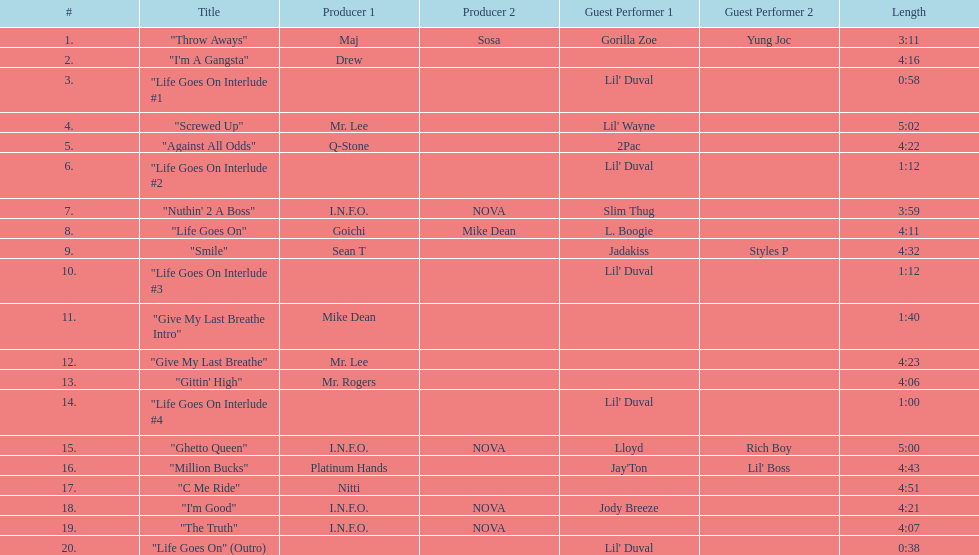What is the total number of tracks on the album? 20. Could you parse the entire table as a dict? {'header': ['#', 'Title', 'Producer 1', 'Producer 2', 'Guest Performer 1', 'Guest Performer 2', 'Length'], 'rows': [['1.', '"Throw Aways"', 'Maj', 'Sosa', 'Gorilla Zoe', 'Yung Joc', '3:11'], ['2.', '"I\'m A Gangsta"', 'Drew', '', '', '', '4:16'], ['3.', '"Life Goes On Interlude #1', '', '', "Lil' Duval", '', '0:58'], ['4.', '"Screwed Up"', 'Mr. Lee', '', "Lil' Wayne", '', '5:02'], ['5.', '"Against All Odds"', 'Q-Stone', '', '2Pac', '', '4:22'], ['6.', '"Life Goes On Interlude #2', '', '', "Lil' Duval", '', '1:12'], ['7.', '"Nuthin\' 2 A Boss"', 'I.N.F.O.', 'NOVA', 'Slim Thug', '', '3:59'], ['8.', '"Life Goes On"', 'Goichi', 'Mike Dean', 'L. Boogie', '', '4:11'], ['9.', '"Smile"', 'Sean T', '', 'Jadakiss', 'Styles P', '4:32'], ['10.', '"Life Goes On Interlude #3', '', '', "Lil' Duval", '', '1:12'], ['11.', '"Give My Last Breathe Intro"', 'Mike Dean', '', '', '', '1:40'], ['12.', '"Give My Last Breathe"', 'Mr. Lee', '', '', '', '4:23'], ['13.', '"Gittin\' High"', 'Mr. Rogers', '', '', '', '4:06'], ['14.', '"Life Goes On Interlude #4', '', '', "Lil' Duval", '', '1:00'], ['15.', '"Ghetto Queen"', 'I.N.F.O.', 'NOVA', 'Lloyd', 'Rich Boy', '5:00'], ['16.', '"Million Bucks"', 'Platinum Hands', '', "Jay'Ton", "Lil' Boss", '4:43'], ['17.', '"C Me Ride"', 'Nitti', '', '', '', '4:51'], ['18.', '"I\'m Good"', 'I.N.F.O.', 'NOVA', 'Jody Breeze', '', '4:21'], ['19.', '"The Truth"', 'I.N.F.O.', 'NOVA', '', '', '4:07'], ['20.', '"Life Goes On" (Outro)', '', '', "Lil' Duval", '', '0:38']]} 